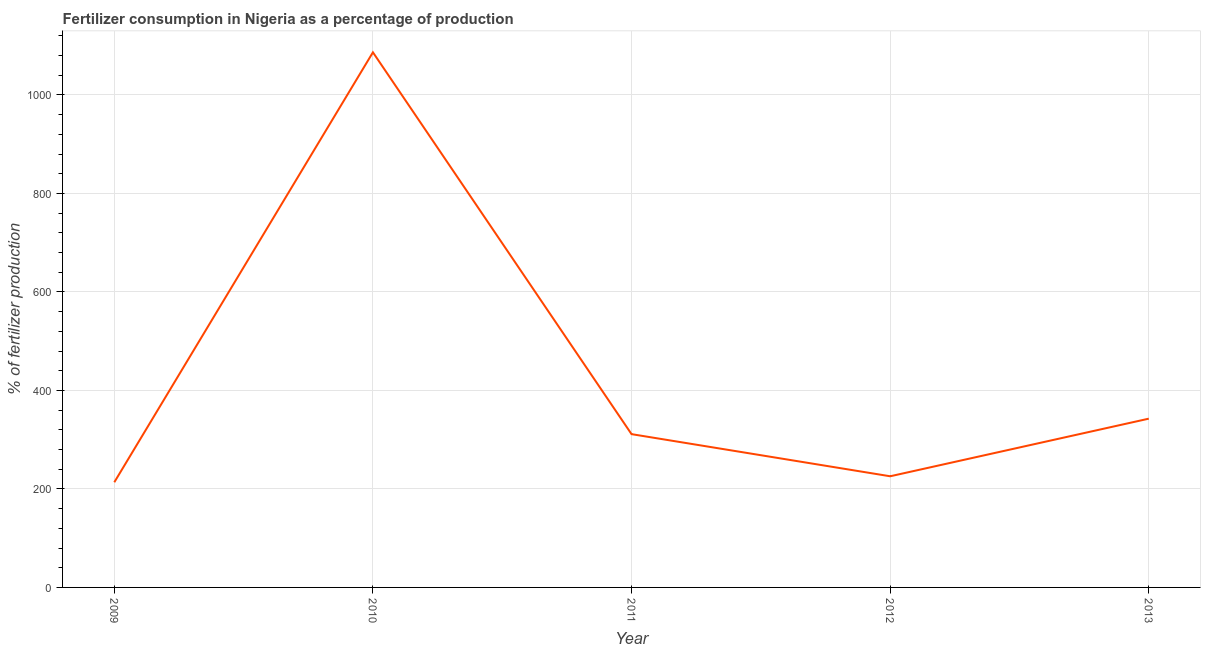What is the amount of fertilizer consumption in 2012?
Your answer should be compact. 225.69. Across all years, what is the maximum amount of fertilizer consumption?
Offer a very short reply. 1086.45. Across all years, what is the minimum amount of fertilizer consumption?
Your response must be concise. 213.51. In which year was the amount of fertilizer consumption maximum?
Your answer should be very brief. 2010. In which year was the amount of fertilizer consumption minimum?
Give a very brief answer. 2009. What is the sum of the amount of fertilizer consumption?
Give a very brief answer. 2179.51. What is the difference between the amount of fertilizer consumption in 2009 and 2010?
Offer a very short reply. -872.94. What is the average amount of fertilizer consumption per year?
Give a very brief answer. 435.9. What is the median amount of fertilizer consumption?
Your answer should be very brief. 311.23. Do a majority of the years between 2009 and 2012 (inclusive) have amount of fertilizer consumption greater than 40 %?
Your answer should be compact. Yes. What is the ratio of the amount of fertilizer consumption in 2010 to that in 2013?
Provide a succinct answer. 3.17. What is the difference between the highest and the second highest amount of fertilizer consumption?
Provide a short and direct response. 743.82. Is the sum of the amount of fertilizer consumption in 2010 and 2011 greater than the maximum amount of fertilizer consumption across all years?
Your response must be concise. Yes. What is the difference between the highest and the lowest amount of fertilizer consumption?
Your response must be concise. 872.94. In how many years, is the amount of fertilizer consumption greater than the average amount of fertilizer consumption taken over all years?
Ensure brevity in your answer.  1. Are the values on the major ticks of Y-axis written in scientific E-notation?
Your response must be concise. No. Does the graph contain grids?
Give a very brief answer. Yes. What is the title of the graph?
Make the answer very short. Fertilizer consumption in Nigeria as a percentage of production. What is the label or title of the Y-axis?
Ensure brevity in your answer.  % of fertilizer production. What is the % of fertilizer production in 2009?
Your response must be concise. 213.51. What is the % of fertilizer production of 2010?
Provide a succinct answer. 1086.45. What is the % of fertilizer production of 2011?
Your response must be concise. 311.23. What is the % of fertilizer production in 2012?
Provide a short and direct response. 225.69. What is the % of fertilizer production in 2013?
Offer a terse response. 342.63. What is the difference between the % of fertilizer production in 2009 and 2010?
Your answer should be compact. -872.94. What is the difference between the % of fertilizer production in 2009 and 2011?
Your answer should be compact. -97.72. What is the difference between the % of fertilizer production in 2009 and 2012?
Offer a terse response. -12.18. What is the difference between the % of fertilizer production in 2009 and 2013?
Give a very brief answer. -129.13. What is the difference between the % of fertilizer production in 2010 and 2011?
Your answer should be compact. 775.22. What is the difference between the % of fertilizer production in 2010 and 2012?
Keep it short and to the point. 860.76. What is the difference between the % of fertilizer production in 2010 and 2013?
Your answer should be compact. 743.82. What is the difference between the % of fertilizer production in 2011 and 2012?
Keep it short and to the point. 85.54. What is the difference between the % of fertilizer production in 2011 and 2013?
Your answer should be compact. -31.4. What is the difference between the % of fertilizer production in 2012 and 2013?
Make the answer very short. -116.95. What is the ratio of the % of fertilizer production in 2009 to that in 2010?
Make the answer very short. 0.2. What is the ratio of the % of fertilizer production in 2009 to that in 2011?
Make the answer very short. 0.69. What is the ratio of the % of fertilizer production in 2009 to that in 2012?
Offer a very short reply. 0.95. What is the ratio of the % of fertilizer production in 2009 to that in 2013?
Make the answer very short. 0.62. What is the ratio of the % of fertilizer production in 2010 to that in 2011?
Your answer should be very brief. 3.49. What is the ratio of the % of fertilizer production in 2010 to that in 2012?
Keep it short and to the point. 4.81. What is the ratio of the % of fertilizer production in 2010 to that in 2013?
Your response must be concise. 3.17. What is the ratio of the % of fertilizer production in 2011 to that in 2012?
Provide a succinct answer. 1.38. What is the ratio of the % of fertilizer production in 2011 to that in 2013?
Make the answer very short. 0.91. What is the ratio of the % of fertilizer production in 2012 to that in 2013?
Offer a very short reply. 0.66. 